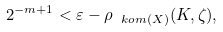Convert formula to latex. <formula><loc_0><loc_0><loc_500><loc_500>2 ^ { - m + 1 } < \varepsilon - \rho _ { \ k o m ( X ) } ( K , \zeta ) ,</formula> 